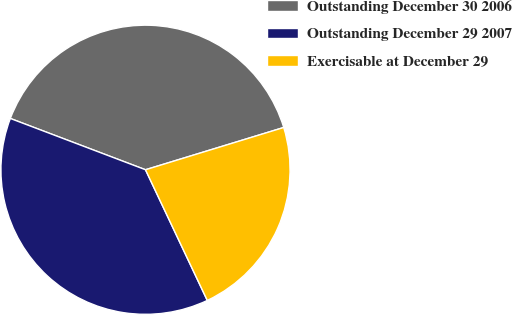<chart> <loc_0><loc_0><loc_500><loc_500><pie_chart><fcel>Outstanding December 30 2006<fcel>Outstanding December 29 2007<fcel>Exercisable at December 29<nl><fcel>39.5%<fcel>37.8%<fcel>22.69%<nl></chart> 